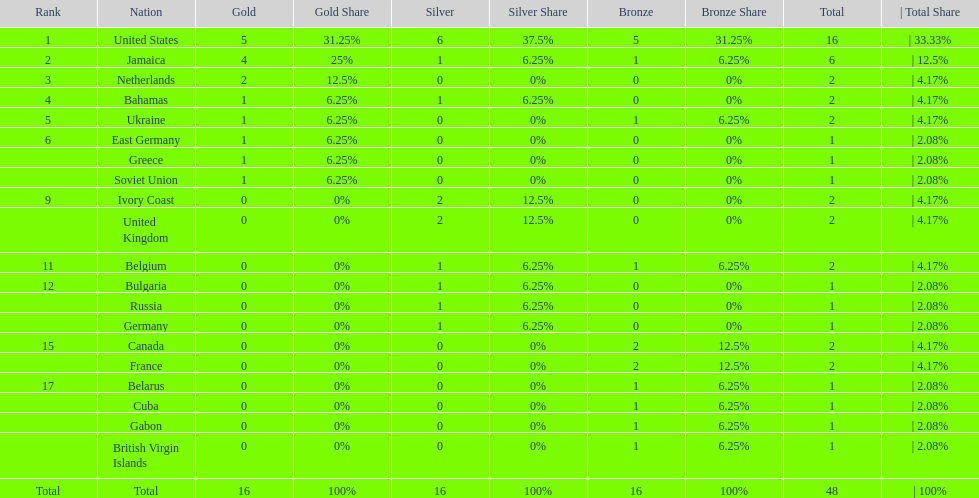How many nations received more medals than canada? 2. 